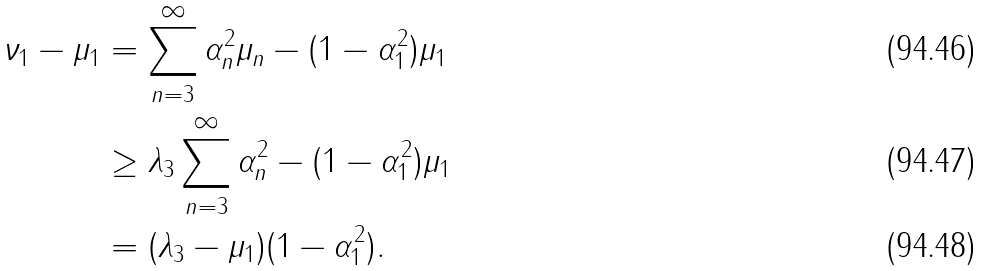Convert formula to latex. <formula><loc_0><loc_0><loc_500><loc_500>\nu _ { 1 } - \mu _ { 1 } & = \sum _ { n = 3 } ^ { \infty } \alpha _ { n } ^ { 2 } \mu _ { n } - ( 1 - \alpha _ { 1 } ^ { 2 } ) \mu _ { 1 } \\ & \geq \lambda _ { 3 } \sum _ { n = 3 } ^ { \infty } \alpha _ { n } ^ { 2 } - ( 1 - \alpha _ { 1 } ^ { 2 } ) \mu _ { 1 } \\ & = ( \lambda _ { 3 } - \mu _ { 1 } ) ( 1 - \alpha _ { 1 } ^ { 2 } ) .</formula> 